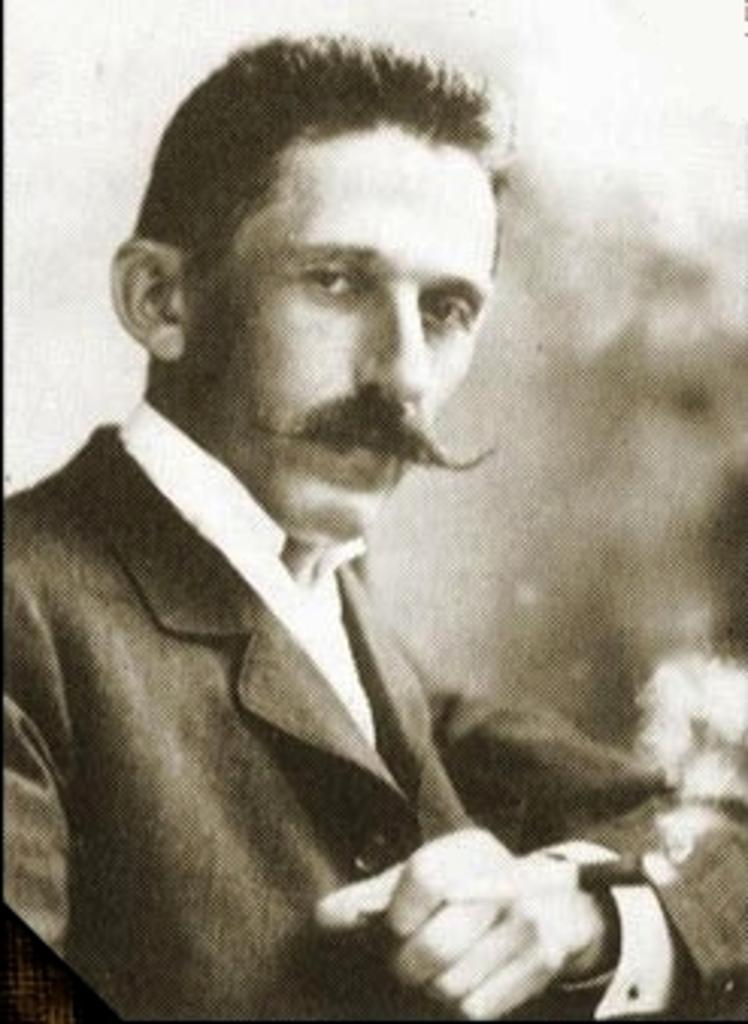Who is the main subject in the image? There is a man in the image. What is the man wearing? The man is wearing a blazer. What is the man's posture in the image? The man appears to be sitting. Can you describe the background of the image? The background of the image is blurry. What is the plot of the story being told in the image? There is no story being told in the image, as it is a still photograph of a man sitting and wearing a blazer. 